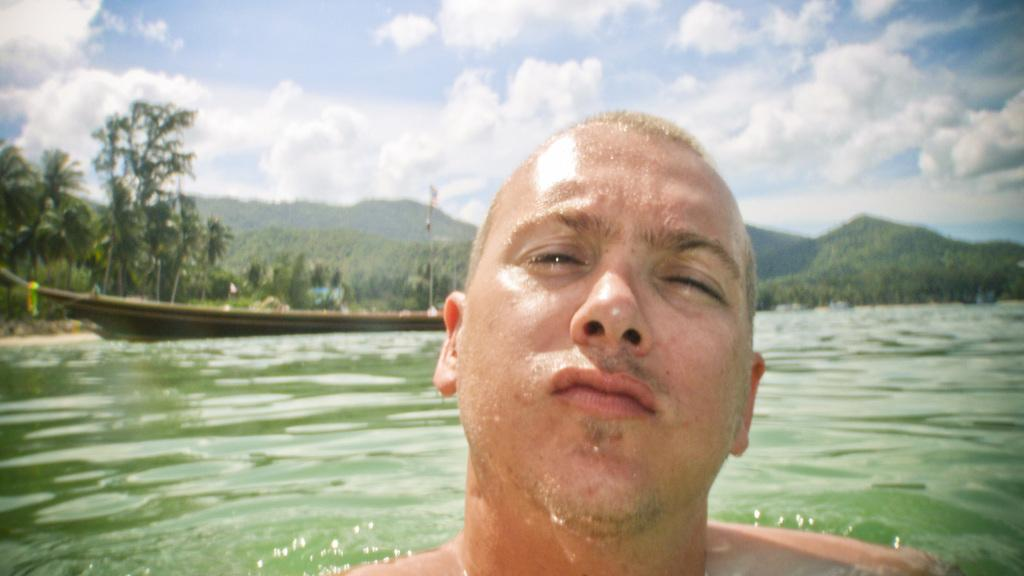What is the main subject of the image? There is a person in the image. What is the person standing near or on? There is water in the image, and the person is likely near or on a ship. Can you describe the surrounding environment? There are trees, hills, and the sky visible in the image. What is the condition of the sky? The sky is visible in the image, and clouds are present. What type of powder is being used by the person in the image? There is no powder visible in the image, and no indication that the person is using any powder. 